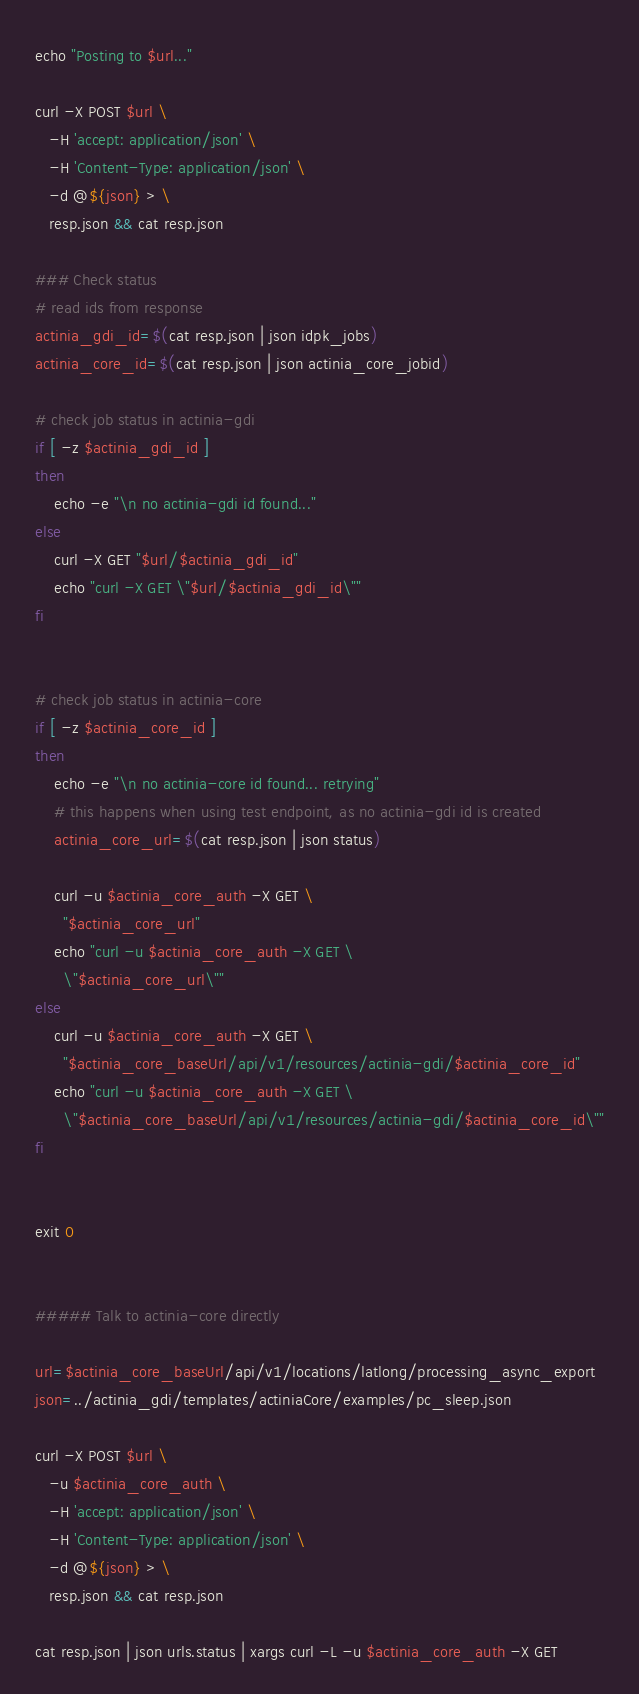<code> <loc_0><loc_0><loc_500><loc_500><_Bash_>echo "Posting to $url..."

curl -X POST $url \
   -H 'accept: application/json' \
   -H 'Content-Type: application/json' \
   -d @${json} > \
   resp.json && cat resp.json

### Check status
# read ids from response
actinia_gdi_id=$(cat resp.json | json idpk_jobs)
actinia_core_id=$(cat resp.json | json actinia_core_jobid)

# check job status in actinia-gdi
if [ -z $actinia_gdi_id ]
then
    echo -e "\n no actinia-gdi id found..."
else
    curl -X GET "$url/$actinia_gdi_id"
    echo "curl -X GET \"$url/$actinia_gdi_id\""
fi


# check job status in actinia-core
if [ -z $actinia_core_id ]
then
    echo -e "\n no actinia-core id found... retrying"
    # this happens when using test endpoint, as no actinia-gdi id is created
    actinia_core_url=$(cat resp.json | json status)

    curl -u $actinia_core_auth -X GET \
      "$actinia_core_url"
    echo "curl -u $actinia_core_auth -X GET \
      \"$actinia_core_url\""
else
    curl -u $actinia_core_auth -X GET \
      "$actinia_core_baseUrl/api/v1/resources/actinia-gdi/$actinia_core_id"
    echo "curl -u $actinia_core_auth -X GET \
      \"$actinia_core_baseUrl/api/v1/resources/actinia-gdi/$actinia_core_id\""
fi


exit 0


##### Talk to actinia-core directly

url=$actinia_core_baseUrl/api/v1/locations/latlong/processing_async_export
json=../actinia_gdi/templates/actiniaCore/examples/pc_sleep.json

curl -X POST $url \
   -u $actinia_core_auth \
   -H 'accept: application/json' \
   -H 'Content-Type: application/json' \
   -d @${json} > \
   resp.json && cat resp.json

cat resp.json | json urls.status | xargs curl -L -u $actinia_core_auth -X GET
</code> 